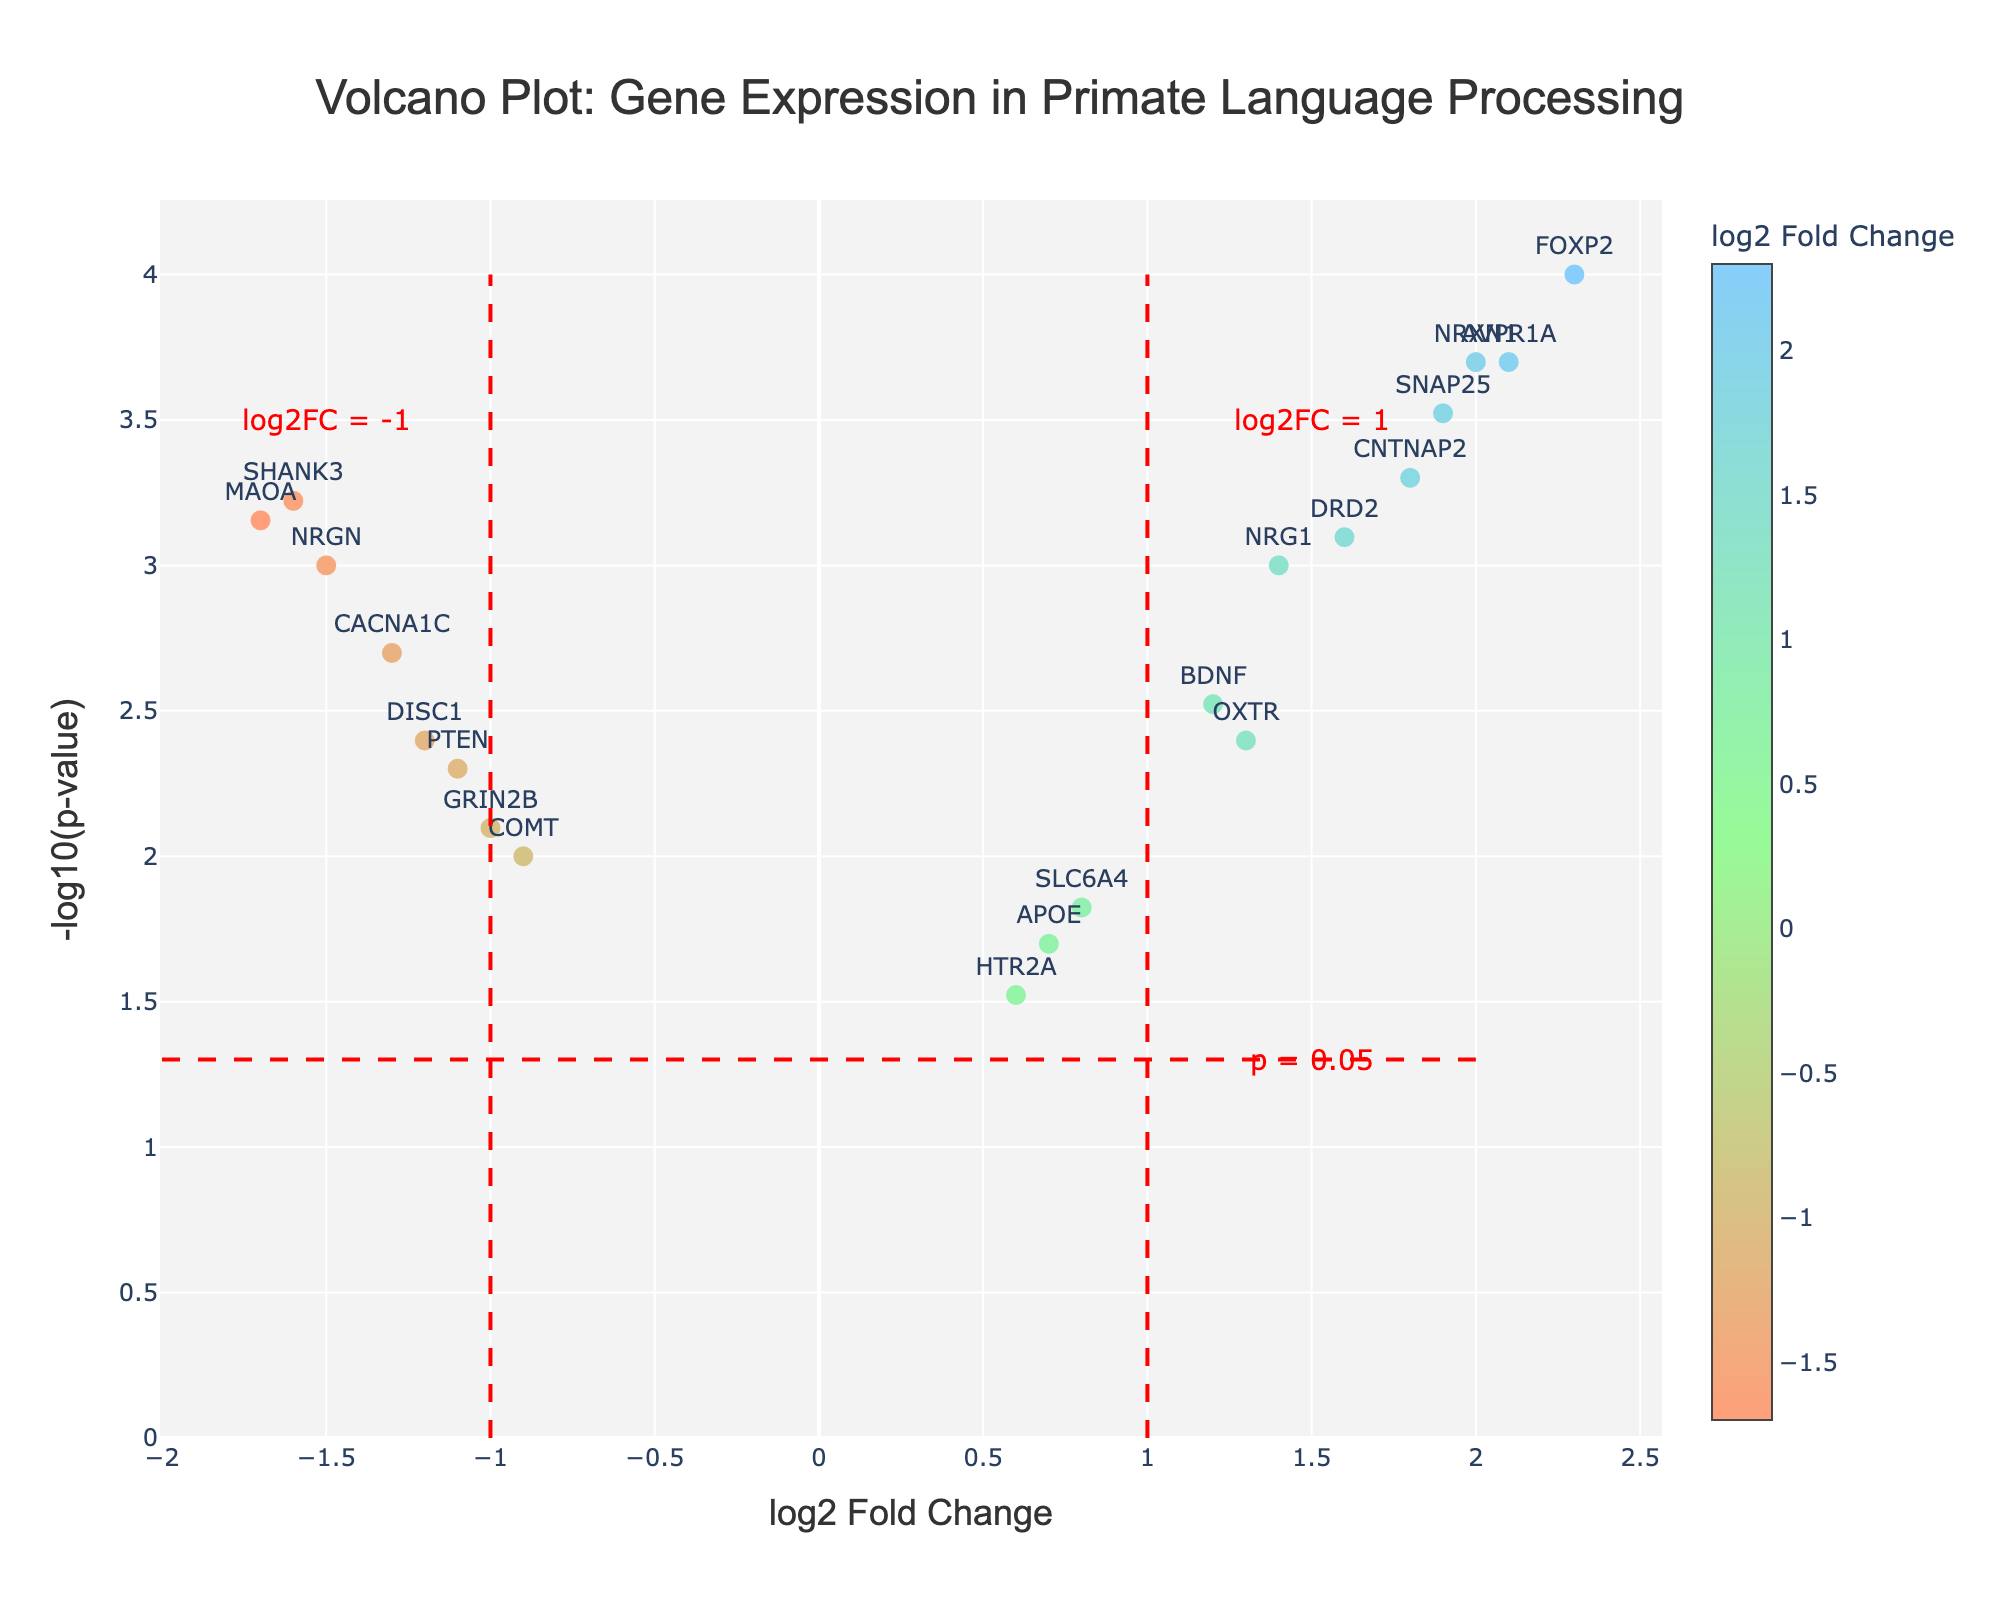What is the title of the figure? The title of the figure is displayed prominently at the top. By reading it, we determine the content and context of the plot.
Answer: Volcano Plot: Gene Expression in Primate Language Processing What are the axes labels on this plot? The x-axis label is "log2 Fold Change," and the y-axis label is "-log10(p-value)." These labels help to identify what each axis represents in the figure.
Answer: log2 Fold Change and -log10(p-value) How many genes have a positive log2 fold change value? To answer this, we identify the data points to the right of the y-axis where log2 fold change is greater than 0.
Answer: 10 Which gene has the highest -log10(p-value) value? We find the data point with the highest y-value, representing the most significant p-value.
Answer: FOXP2 What is the log2 fold change for FOXP2? According to the hover information or the text near the data point, we check the log2 fold change for FOXP2.
Answer: 2.3 Which genes are significantly upregulated based on the fold change and p-value thresholds noted in the plot? "Significant upregulation" can be defined by a log2 fold change > 1 and a p-value < 0.05. We find genes meeting these criteria, indicated by the positions and annotations in the plot.
Answer: FOXP2, CNTNAP2, AVPR1A, SNAP25, NRXN1 How many genes have a log2 fold change between -1 and 1? We count the number of data points between -1 and 1 on the x-axis as highlighted by the vertical threshold lines at these values.
Answer: 5 Which genes are most significantly downregulated with a log2 fold change less than -1? "Most significantly downregulated" implies a high -log10(p-value) and a log2 fold change < -1. We identify these from their positions below the -1 line on the x-axis and high on the y-axis.
Answer: NRGN, MAOA, CACNA1C, DISC1, SHANK3 What does the red dashed horizontal line represent in the plot? The red dashed horizontal line represents the p-value threshold of 0.05, as indicated by the annotation next to the line.
Answer: p = 0.05 threshold How does the log2 fold change of DRD2 compare to that of MAOA? We need to compare the x-values of DRD2 and MAOA; DRD2 has a positive log2 fold change, while MAOA has a negative one, making DRD2 higher.
Answer: DRD2's log2 fold change is higher 